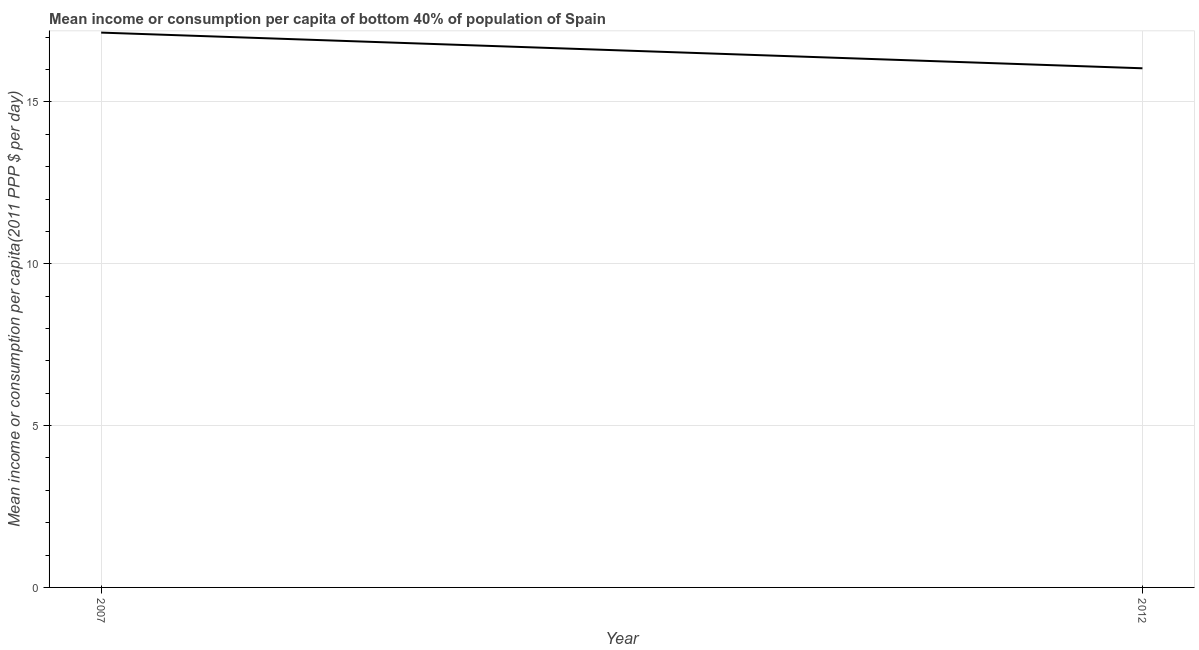What is the mean income or consumption in 2012?
Your response must be concise. 16.04. Across all years, what is the maximum mean income or consumption?
Your answer should be very brief. 17.14. Across all years, what is the minimum mean income or consumption?
Make the answer very short. 16.04. In which year was the mean income or consumption minimum?
Ensure brevity in your answer.  2012. What is the sum of the mean income or consumption?
Keep it short and to the point. 33.18. What is the difference between the mean income or consumption in 2007 and 2012?
Provide a succinct answer. 1.1. What is the average mean income or consumption per year?
Your response must be concise. 16.59. What is the median mean income or consumption?
Make the answer very short. 16.59. In how many years, is the mean income or consumption greater than 4 $?
Give a very brief answer. 2. What is the ratio of the mean income or consumption in 2007 to that in 2012?
Your answer should be compact. 1.07. In how many years, is the mean income or consumption greater than the average mean income or consumption taken over all years?
Ensure brevity in your answer.  1. What is the difference between two consecutive major ticks on the Y-axis?
Ensure brevity in your answer.  5. Does the graph contain grids?
Your response must be concise. Yes. What is the title of the graph?
Make the answer very short. Mean income or consumption per capita of bottom 40% of population of Spain. What is the label or title of the Y-axis?
Your answer should be compact. Mean income or consumption per capita(2011 PPP $ per day). What is the Mean income or consumption per capita(2011 PPP $ per day) in 2007?
Provide a succinct answer. 17.14. What is the Mean income or consumption per capita(2011 PPP $ per day) of 2012?
Provide a succinct answer. 16.04. What is the difference between the Mean income or consumption per capita(2011 PPP $ per day) in 2007 and 2012?
Provide a succinct answer. 1.1. What is the ratio of the Mean income or consumption per capita(2011 PPP $ per day) in 2007 to that in 2012?
Make the answer very short. 1.07. 